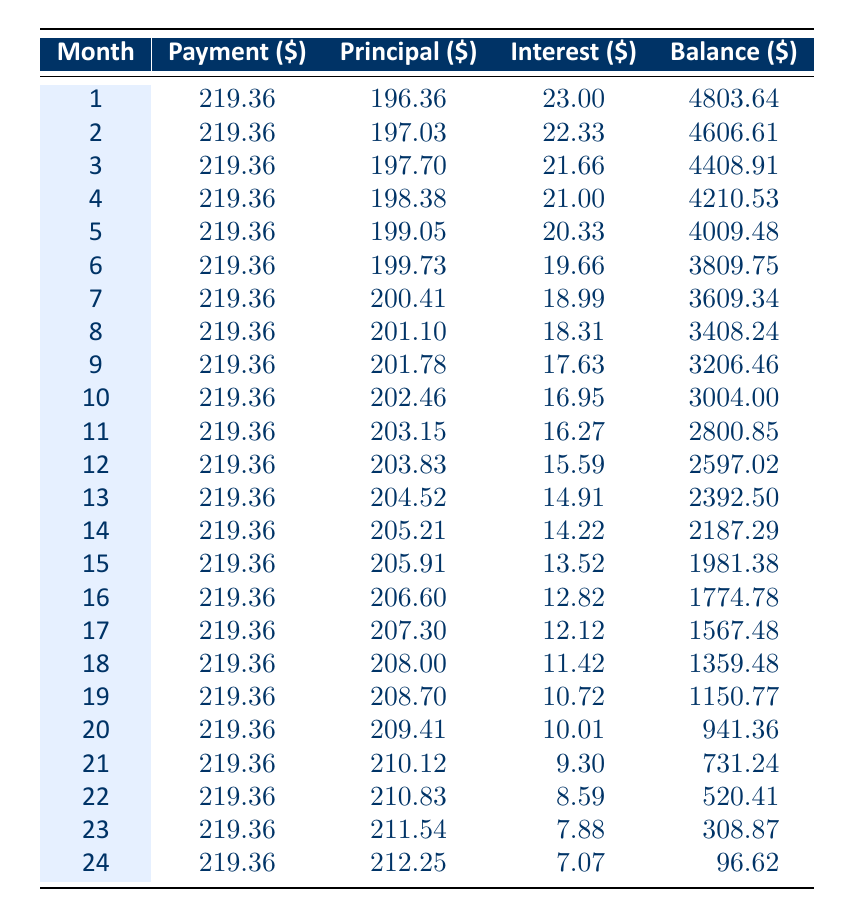What is the total amount of interest paid over the full term of the loan? To find the total interest paid, we can sum the interest paid each month for 24 months. The sum of interest from all rows (23.00 + 22.33 + 21.66 + ... + 7.07) gives us a total interest of approximately 256.20.
Answer: 256.20 What was the balance remaining after the 12th payment? The balance remaining can be found in the row for month 12, which is 2597.02.
Answer: 2597.02 Is the principal payment increasing every month? By observing the principal column, we can see that each month the amount of principal paid is increasing steadily, indicating a consistent repayment strategy.
Answer: Yes What is the monthly payment amount throughout the loan term? Referring to any month in the payment column shows that the monthly payment remains consistent at 219.36.
Answer: 219.36 What was the principal amount paid in the 24th month? Checking the month 24 row reveals that the principal payment for that month is 212.25.
Answer: 212.25 What is the average monthly principal payment over the loan term? The average can be calculated by summing all principal payments (196.36 + 197.03 + 197.70 + ... + 212.25) and dividing by 24. The total principal is approximately 4,351.66, so the average is 4,351.66 / 24 = 181.32.
Answer: 181.32 How much did the balance decrease from the first to the last month? The balance starts at 5000 and ends at 96.62, so the decrease is calculated as 5000 - 96.62 = 4903.38.
Answer: 4903.38 Which month had the highest principal payment, and what was that amount? By examining the principal column, we see that the highest principal payment was in month 24 at 212.25.
Answer: Month 24, 212.25 Is the total monthly payment remaining constant across all months in the table? All monthly payments are consistently listed as 219.36, indicating no variation.
Answer: Yes 